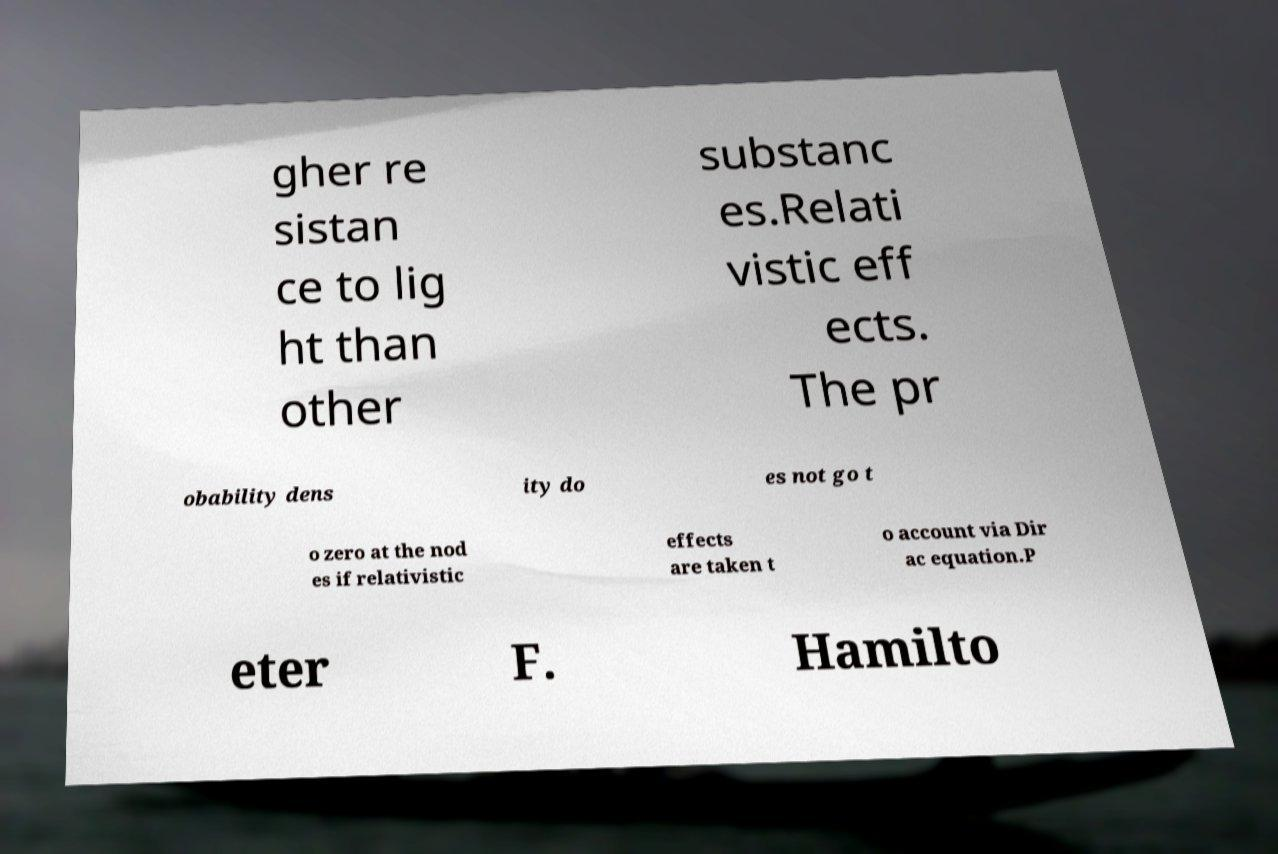Please identify and transcribe the text found in this image. gher re sistan ce to lig ht than other substanc es.Relati vistic eff ects. The pr obability dens ity do es not go t o zero at the nod es if relativistic effects are taken t o account via Dir ac equation.P eter F. Hamilto 